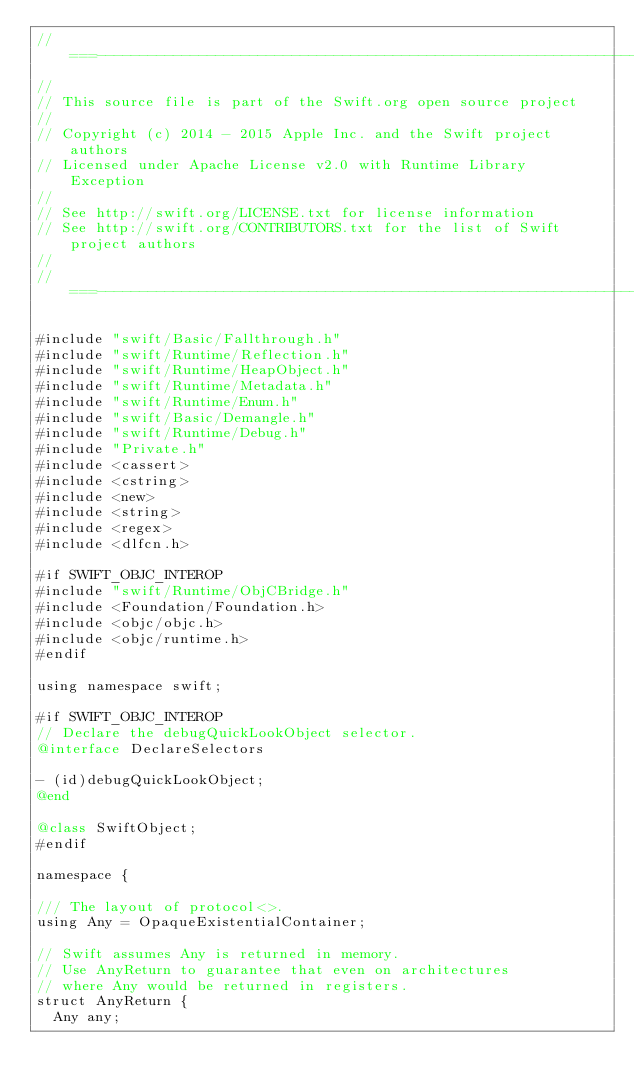Convert code to text. <code><loc_0><loc_0><loc_500><loc_500><_ObjectiveC_>//===----------------------------------------------------------------------===//
//
// This source file is part of the Swift.org open source project
//
// Copyright (c) 2014 - 2015 Apple Inc. and the Swift project authors
// Licensed under Apache License v2.0 with Runtime Library Exception
//
// See http://swift.org/LICENSE.txt for license information
// See http://swift.org/CONTRIBUTORS.txt for the list of Swift project authors
//
//===----------------------------------------------------------------------===//

#include "swift/Basic/Fallthrough.h"
#include "swift/Runtime/Reflection.h"
#include "swift/Runtime/HeapObject.h"
#include "swift/Runtime/Metadata.h"
#include "swift/Runtime/Enum.h"
#include "swift/Basic/Demangle.h"
#include "swift/Runtime/Debug.h"
#include "Private.h"
#include <cassert>
#include <cstring>
#include <new>
#include <string>
#include <regex>
#include <dlfcn.h>

#if SWIFT_OBJC_INTEROP
#include "swift/Runtime/ObjCBridge.h"
#include <Foundation/Foundation.h>
#include <objc/objc.h>
#include <objc/runtime.h>
#endif

using namespace swift;

#if SWIFT_OBJC_INTEROP
// Declare the debugQuickLookObject selector.
@interface DeclareSelectors

- (id)debugQuickLookObject;
@end

@class SwiftObject;
#endif

namespace {
  
/// The layout of protocol<>.
using Any = OpaqueExistentialContainer;

// Swift assumes Any is returned in memory. 
// Use AnyReturn to guarantee that even on architectures 
// where Any would be returned in registers.
struct AnyReturn {
  Any any;</code> 